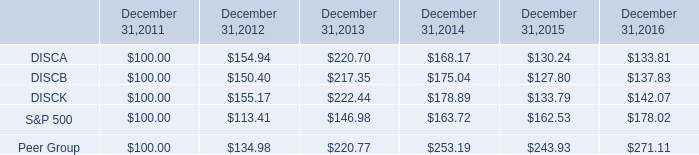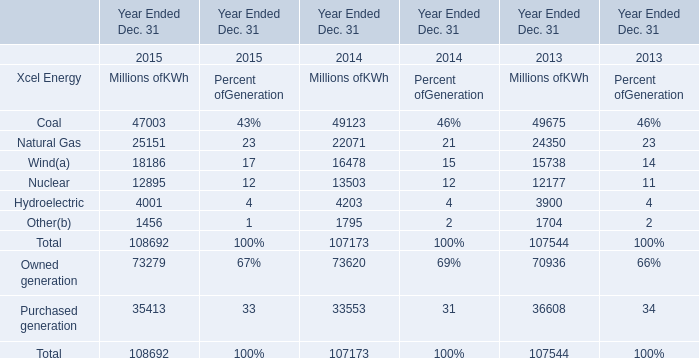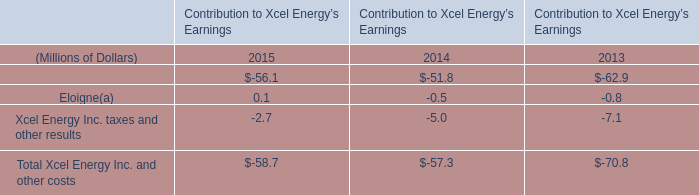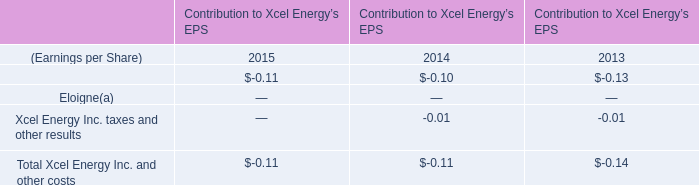What is the proportion of all Xcel Energy that are greater than 20000 to the total amount of Xcel Energy, in 2015? 
Computations: ((47003 + 25151) / (((((47003 + 25151) + 18186) + 12895) + 4001) + 1456))
Answer: 0.66384. 